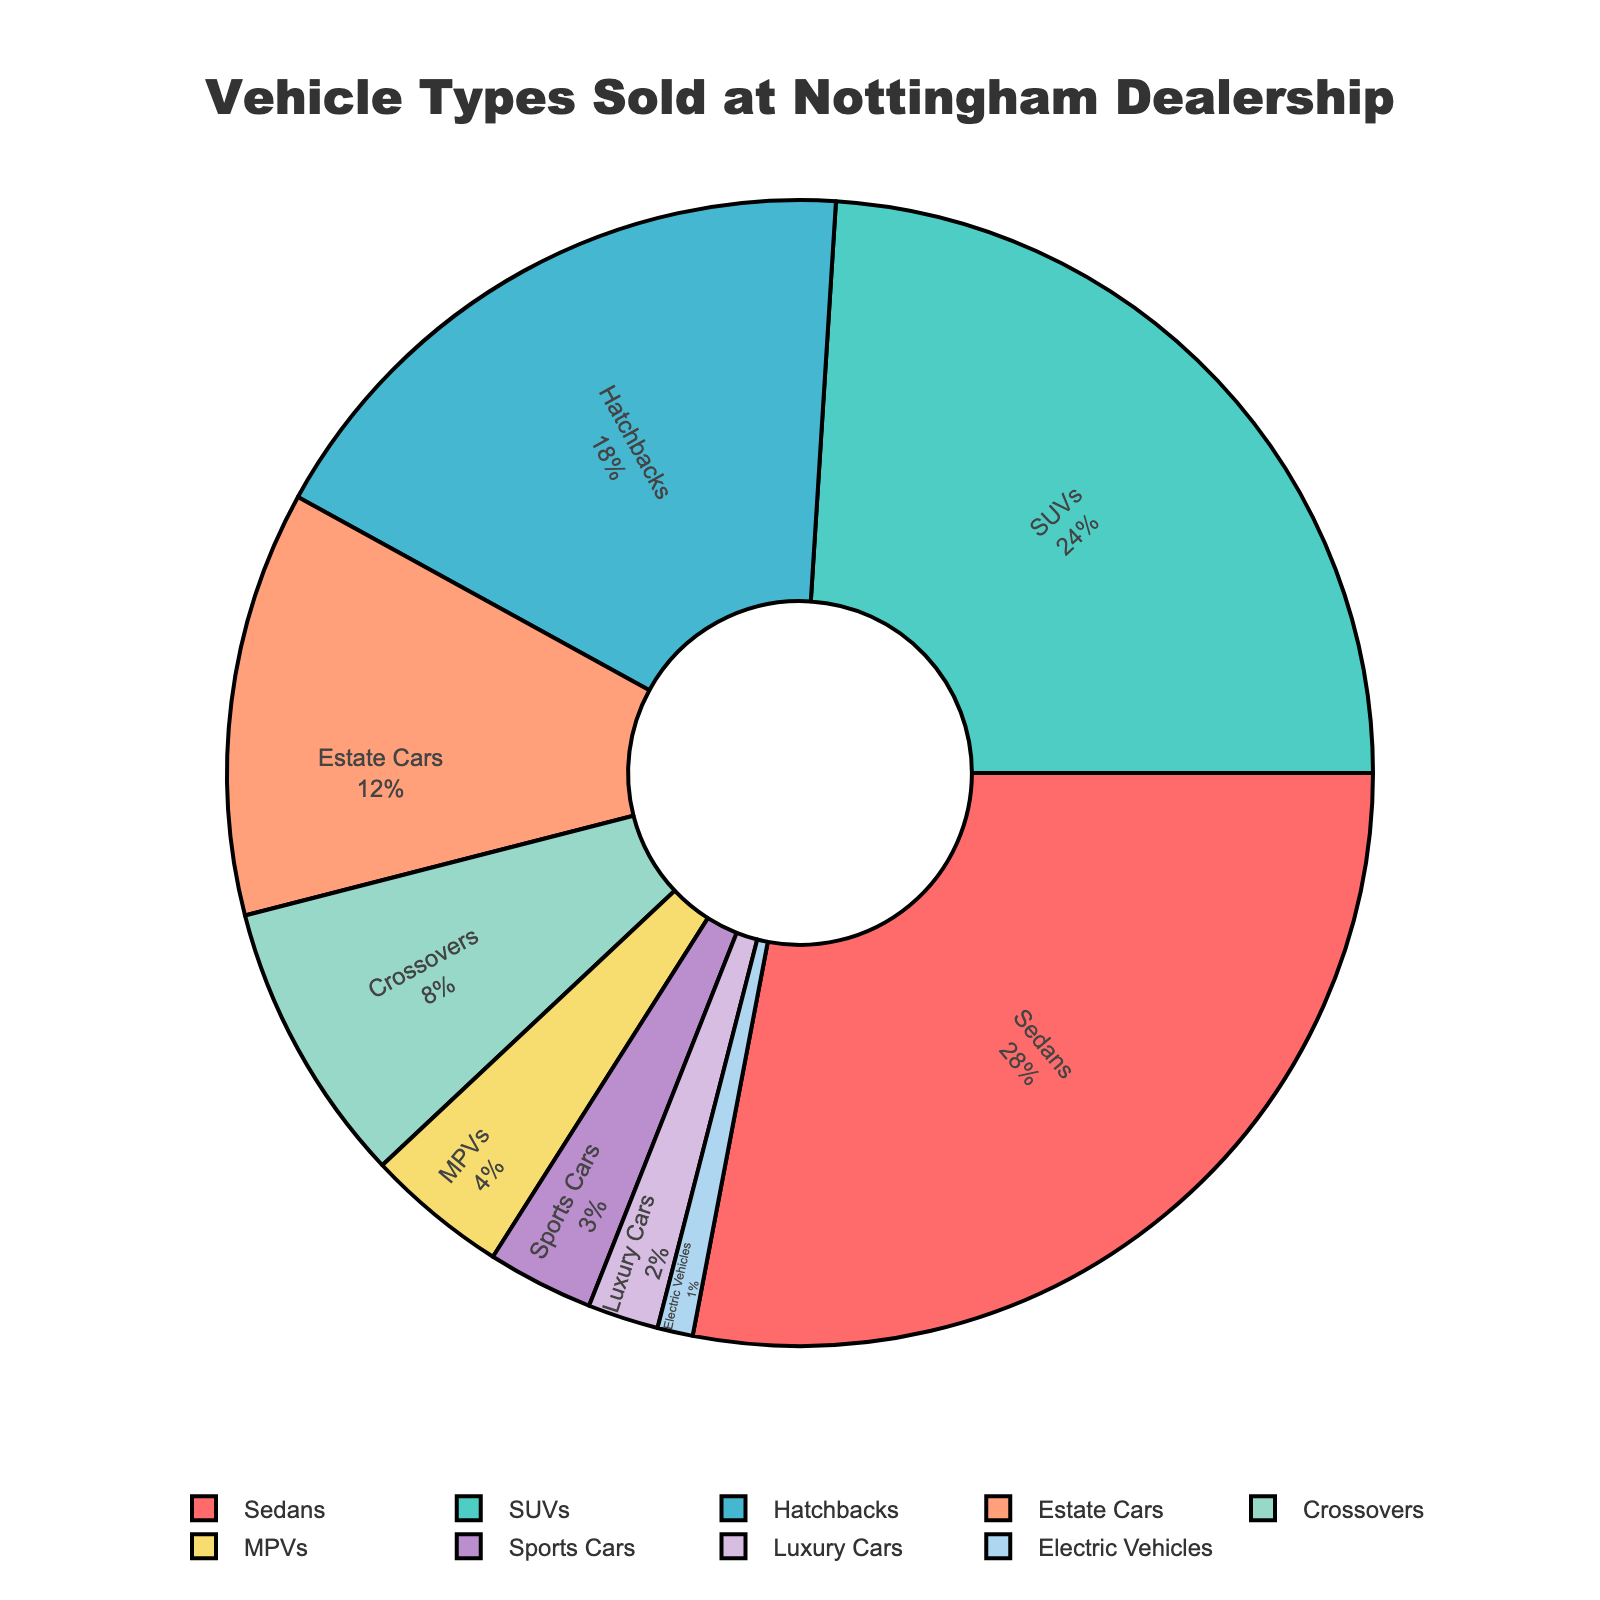Which vehicle type is sold the most? On the pie chart, the largest section represents the most sold vehicle type, which is labeled "Sedans" with 28%.
Answer: Sedans How many percentage points more of Sedans are sold compared to Crossovers? The percentage of Sedans sold is 28%, and Crossovers is 8%. The difference in their sales percentage is calculated by subtracting 8 from 28.
Answer: 20 What is the combined percentage of SUVs and Hatchbacks sold? The pie chart shows SUVs at 24% and Hatchbacks at 18%. Adding these two gives the total percentage: 24 + 18 = 42%.
Answer: 42% Which vehicle type is sold the least? The smallest section of the pie chart represents the least sold vehicle type, which is labeled "Electric Vehicles" with 1%.
Answer: Electric Vehicles Are there more Sports Cars or MPVs sold? By examining the sections on the pie chart labeled "Sports Cars" and "MPVs," we can see that Sports Cars have 3% and MPVs have 4%. Since 4% is greater than 3%, more MPVs are sold.
Answer: MPVs What is the combined percentage of all vehicle types other than Sedans? The percentage for Sedans is 28%. Subtracting this from 100% gives the combined percentage of all other vehicle types: 100 - 28 = 72%.
Answer: 72% Which vehicle type has the second-highest percentage of sales? The second-largest section in the pie chart after Sedans (28%) is SUVs, which is 24%.
Answer: SUVs How much more is the percentage of Estate Cars sold compared to Luxury Cars? Estate Cars have 12% and Luxury Cars have 2%. Subtracting the percentage of Luxury Cars from Estate Cars gives: 12 - 2 = 10%.
Answer: 10 What percentage of total sales is made up by Crossovers and Electric Vehicles? Crossovers account for 8% of sales and Electric Vehicles for 1%. Adding these gives: 8 + 1 = 9%.
Answer: 9% What is the average percentage of sales for Sports Cars, Luxury Cars, and Electric Vehicles? Adding the percentages for Sports Cars (3%), Luxury Cars (2%), and Electric Vehicles (1%) gives a total of 6%. Dividing this by the number of vehicle types (3) gives the average: 6 / 3 = 2%.
Answer: 2% 